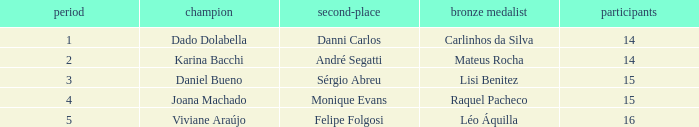Who finished in third place when the winner was Karina Bacchi?  Mateus Rocha. 